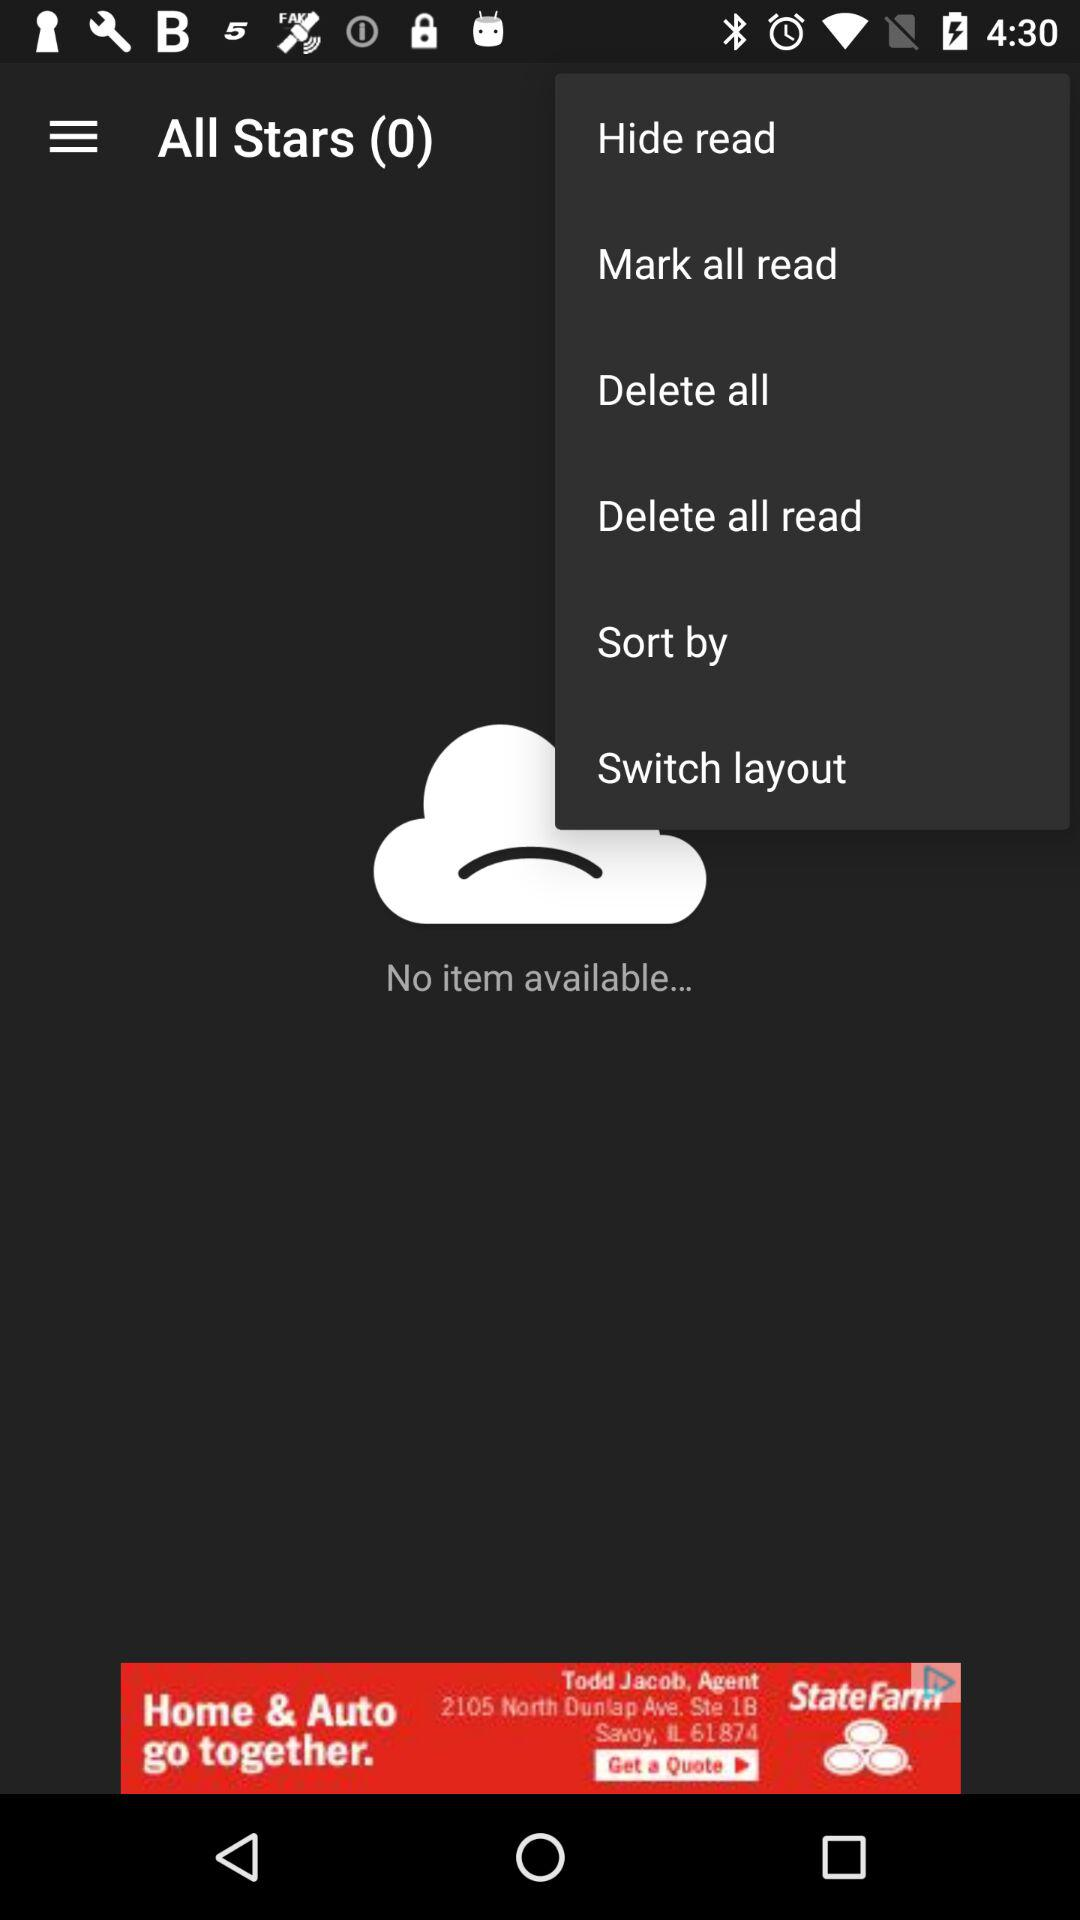How many unread messages are in "All Stars"? There are 0 unread messages. 